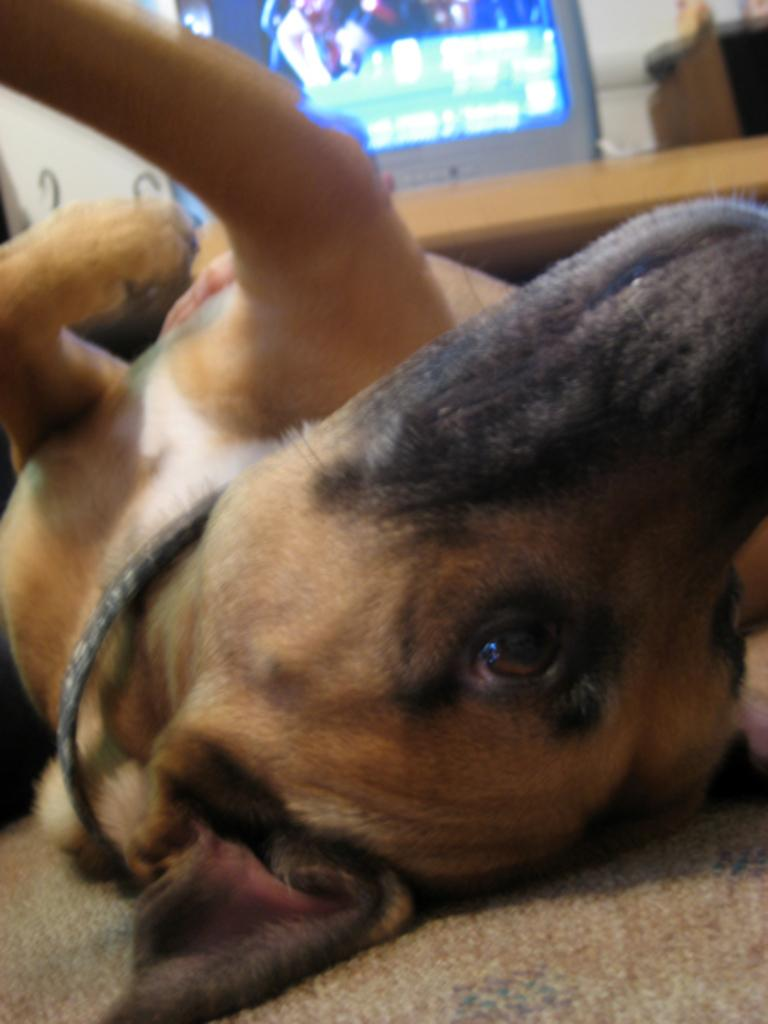What animal can be seen lying on the floor in the image? There is a dog lying on the floor in the image. What electronic device is present in the image? There is a TV in the image. What object is on a table in the image? There is a box on a table in the image. What part of the natural environment is visible in the image? The sky is visible in the image. What type of lipstick is the dog wearing in the image? There is no lipstick or any indication of the dog wearing lipstick in the image. 